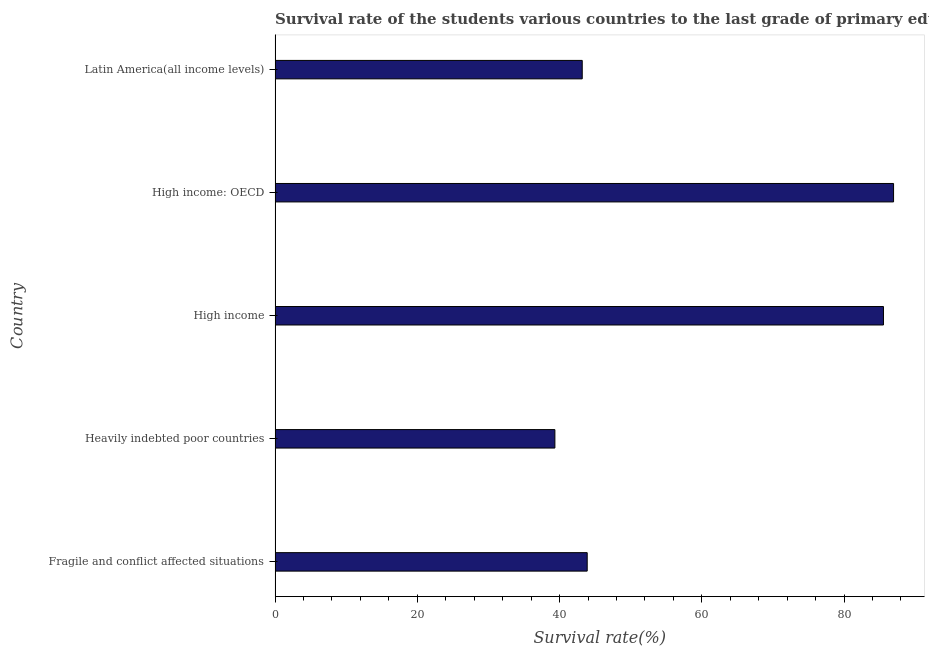What is the title of the graph?
Your response must be concise. Survival rate of the students various countries to the last grade of primary education. What is the label or title of the X-axis?
Offer a very short reply. Survival rate(%). What is the label or title of the Y-axis?
Your response must be concise. Country. What is the survival rate in primary education in High income?
Give a very brief answer. 85.55. Across all countries, what is the maximum survival rate in primary education?
Your response must be concise. 86.97. Across all countries, what is the minimum survival rate in primary education?
Your answer should be compact. 39.34. In which country was the survival rate in primary education maximum?
Provide a succinct answer. High income: OECD. In which country was the survival rate in primary education minimum?
Give a very brief answer. Heavily indebted poor countries. What is the sum of the survival rate in primary education?
Give a very brief answer. 298.93. What is the difference between the survival rate in primary education in High income: OECD and Latin America(all income levels)?
Keep it short and to the point. 43.78. What is the average survival rate in primary education per country?
Your answer should be very brief. 59.79. What is the median survival rate in primary education?
Keep it short and to the point. 43.89. What is the ratio of the survival rate in primary education in Heavily indebted poor countries to that in High income: OECD?
Offer a terse response. 0.45. What is the difference between the highest and the second highest survival rate in primary education?
Offer a terse response. 1.42. Is the sum of the survival rate in primary education in Fragile and conflict affected situations and High income: OECD greater than the maximum survival rate in primary education across all countries?
Provide a succinct answer. Yes. What is the difference between the highest and the lowest survival rate in primary education?
Your answer should be compact. 47.62. How many countries are there in the graph?
Give a very brief answer. 5. Are the values on the major ticks of X-axis written in scientific E-notation?
Ensure brevity in your answer.  No. What is the Survival rate(%) of Fragile and conflict affected situations?
Provide a short and direct response. 43.89. What is the Survival rate(%) of Heavily indebted poor countries?
Your response must be concise. 39.34. What is the Survival rate(%) of High income?
Provide a short and direct response. 85.55. What is the Survival rate(%) in High income: OECD?
Keep it short and to the point. 86.97. What is the Survival rate(%) in Latin America(all income levels)?
Your answer should be compact. 43.19. What is the difference between the Survival rate(%) in Fragile and conflict affected situations and Heavily indebted poor countries?
Give a very brief answer. 4.54. What is the difference between the Survival rate(%) in Fragile and conflict affected situations and High income?
Your response must be concise. -41.66. What is the difference between the Survival rate(%) in Fragile and conflict affected situations and High income: OECD?
Keep it short and to the point. -43.08. What is the difference between the Survival rate(%) in Fragile and conflict affected situations and Latin America(all income levels)?
Your answer should be compact. 0.7. What is the difference between the Survival rate(%) in Heavily indebted poor countries and High income?
Give a very brief answer. -46.2. What is the difference between the Survival rate(%) in Heavily indebted poor countries and High income: OECD?
Give a very brief answer. -47.62. What is the difference between the Survival rate(%) in Heavily indebted poor countries and Latin America(all income levels)?
Ensure brevity in your answer.  -3.85. What is the difference between the Survival rate(%) in High income and High income: OECD?
Ensure brevity in your answer.  -1.42. What is the difference between the Survival rate(%) in High income and Latin America(all income levels)?
Offer a terse response. 42.36. What is the difference between the Survival rate(%) in High income: OECD and Latin America(all income levels)?
Provide a short and direct response. 43.78. What is the ratio of the Survival rate(%) in Fragile and conflict affected situations to that in Heavily indebted poor countries?
Offer a very short reply. 1.12. What is the ratio of the Survival rate(%) in Fragile and conflict affected situations to that in High income?
Offer a very short reply. 0.51. What is the ratio of the Survival rate(%) in Fragile and conflict affected situations to that in High income: OECD?
Offer a very short reply. 0.51. What is the ratio of the Survival rate(%) in Fragile and conflict affected situations to that in Latin America(all income levels)?
Offer a terse response. 1.02. What is the ratio of the Survival rate(%) in Heavily indebted poor countries to that in High income?
Offer a terse response. 0.46. What is the ratio of the Survival rate(%) in Heavily indebted poor countries to that in High income: OECD?
Ensure brevity in your answer.  0.45. What is the ratio of the Survival rate(%) in Heavily indebted poor countries to that in Latin America(all income levels)?
Offer a terse response. 0.91. What is the ratio of the Survival rate(%) in High income to that in Latin America(all income levels)?
Offer a terse response. 1.98. What is the ratio of the Survival rate(%) in High income: OECD to that in Latin America(all income levels)?
Provide a short and direct response. 2.01. 